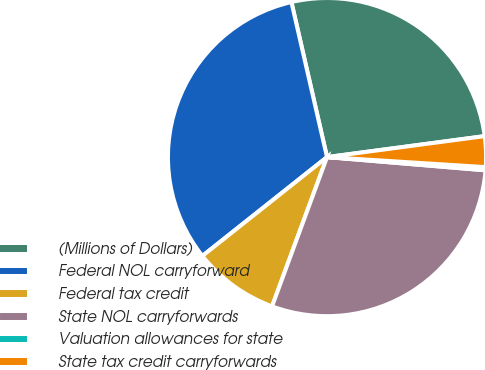Convert chart. <chart><loc_0><loc_0><loc_500><loc_500><pie_chart><fcel>(Millions of Dollars)<fcel>Federal NOL carryforward<fcel>Federal tax credit<fcel>State NOL carryforwards<fcel>Valuation allowances for state<fcel>State tax credit carryforwards<nl><fcel>26.49%<fcel>32.08%<fcel>8.71%<fcel>29.29%<fcel>0.32%<fcel>3.11%<nl></chart> 